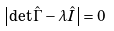<formula> <loc_0><loc_0><loc_500><loc_500>\left | { \det \hat { \Gamma } - \lambda \hat { I } } \right | = 0</formula> 